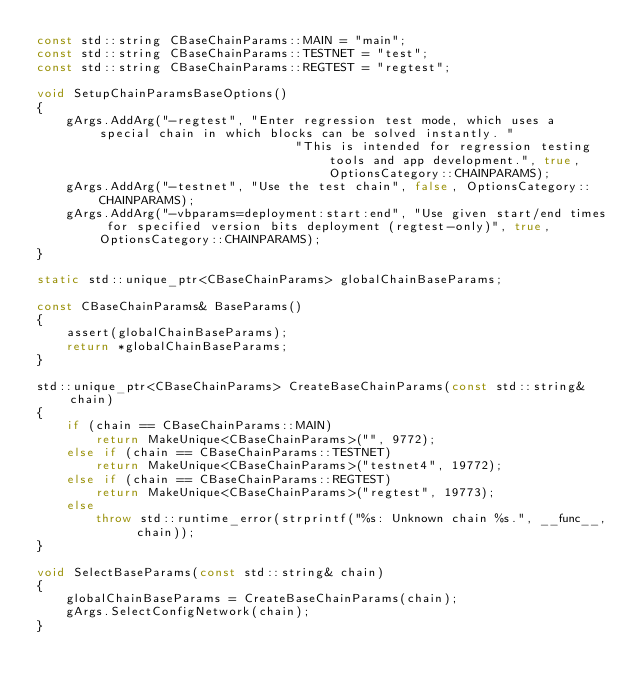Convert code to text. <code><loc_0><loc_0><loc_500><loc_500><_C++_>const std::string CBaseChainParams::MAIN = "main";
const std::string CBaseChainParams::TESTNET = "test";
const std::string CBaseChainParams::REGTEST = "regtest";

void SetupChainParamsBaseOptions()
{
    gArgs.AddArg("-regtest", "Enter regression test mode, which uses a special chain in which blocks can be solved instantly. "
                                   "This is intended for regression testing tools and app development.", true, OptionsCategory::CHAINPARAMS);
    gArgs.AddArg("-testnet", "Use the test chain", false, OptionsCategory::CHAINPARAMS);
    gArgs.AddArg("-vbparams=deployment:start:end", "Use given start/end times for specified version bits deployment (regtest-only)", true, OptionsCategory::CHAINPARAMS);
}

static std::unique_ptr<CBaseChainParams> globalChainBaseParams;

const CBaseChainParams& BaseParams()
{
    assert(globalChainBaseParams);
    return *globalChainBaseParams;
}

std::unique_ptr<CBaseChainParams> CreateBaseChainParams(const std::string& chain)
{
    if (chain == CBaseChainParams::MAIN)
        return MakeUnique<CBaseChainParams>("", 9772);
    else if (chain == CBaseChainParams::TESTNET)
        return MakeUnique<CBaseChainParams>("testnet4", 19772);
    else if (chain == CBaseChainParams::REGTEST)
        return MakeUnique<CBaseChainParams>("regtest", 19773);
    else
        throw std::runtime_error(strprintf("%s: Unknown chain %s.", __func__, chain));
}

void SelectBaseParams(const std::string& chain)
{
    globalChainBaseParams = CreateBaseChainParams(chain);
    gArgs.SelectConfigNetwork(chain);
}
</code> 